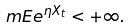Convert formula to latex. <formula><loc_0><loc_0><loc_500><loc_500>\ m E e ^ { \eta X _ { t } } < + \infty .</formula> 